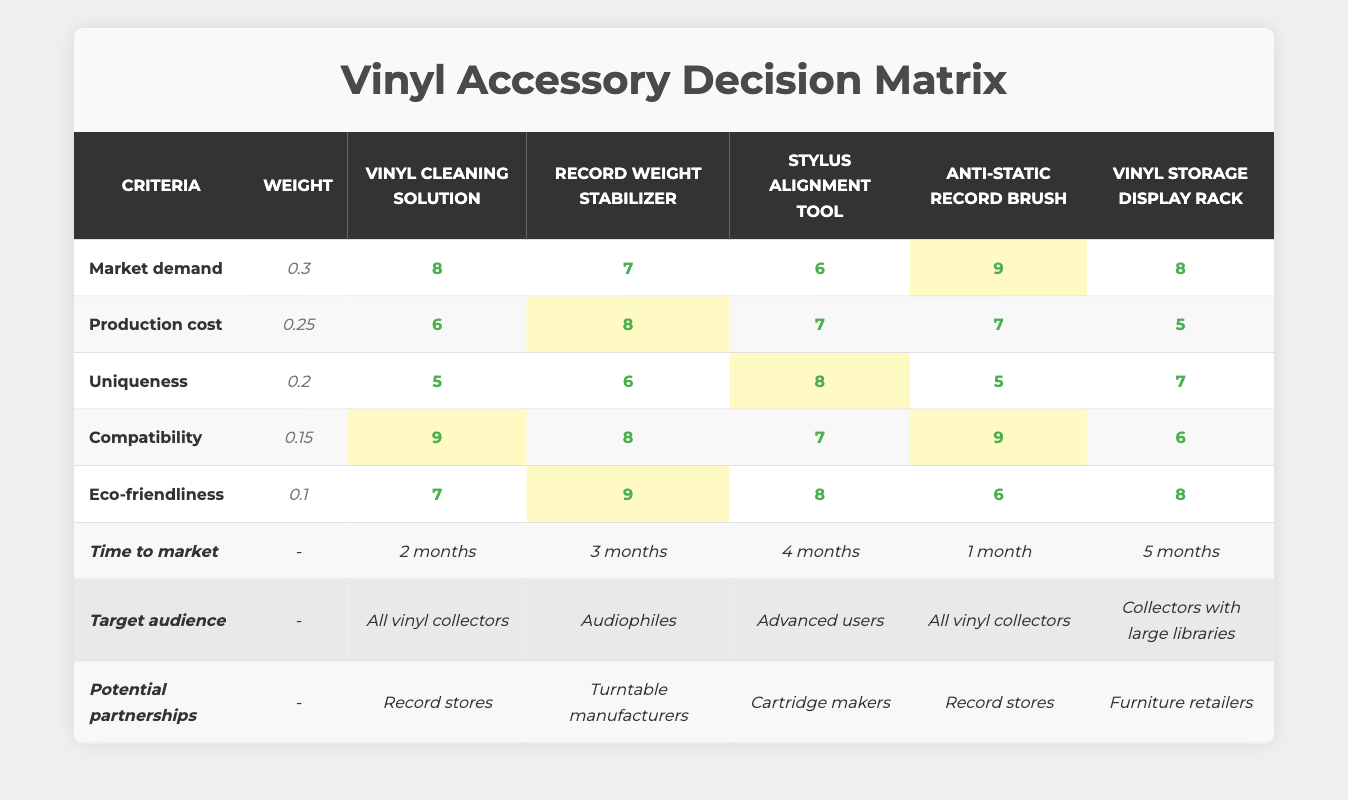What is the score for Eco-friendliness for the Record weight stabilizer? The score for Eco-friendliness is listed under the Record weight stabilizer column in the Eco-friendliness row. The value there is 9.
Answer: 9 Which accessory has the highest score for Market demand? To determine the highest score in the Market demand row, we can compare the individual scores: Vinyl cleaning solution (8), Record weight stabilizer (7), Stylus alignment tool (6), Anti-static record brush (9), and Vinyl storage display rack (8). The highest score is 9 for the Anti-static record brush.
Answer: 9 What is the total score for the Vinyl cleaning solution? The scores for the Vinyl cleaning solution are scored under each criterion: Market demand (8), Production cost (6), Uniqueness (5), Compatibility (9), and Eco-friendliness (7). Summing these values gives us 8 + 6 + 5 + 9 + 7 = 35.
Answer: 35 Which accessory has the fastest Time to market, and what is it? We can compare the times listed for each accessory: Vinyl cleaning solution (2 months), Record weight stabilizer (3 months), Stylus alignment tool (4 months), Anti-static record brush (1 month), and Vinyl storage display rack (5 months). The fastest is the Anti-static record brush with 1 month.
Answer: Anti-static record brush, 1 month Is the Stylus alignment tool compatible with all vinyl collectors? Looking at the Compatibility row, the score for the Stylus alignment tool is 7, which indicates it is not specifically aimed at all vinyl collectors. The target audience for the Stylus alignment tool is described as Advanced users. Therefore, the fact is false.
Answer: No What would be the average score for Compatibility among all accessories? The individual scores for Compatibility are: Vinyl cleaning solution (9), Record weight stabilizer (8), Stylus alignment tool (7), Anti-static record brush (9), and Vinyl storage display rack (6). We first sum the scores: 9 + 8 + 7 + 9 + 6 = 39. There are 5 accessories, so we calculate the average as 39/5 = 7.8.
Answer: 7.8 Which accessory targets Advanced users, and what partnerships can it pursue? The Stylus alignment tool is identified as targeting Advanced users. According to the Potential partnerships row, it can pursue partnerships with Cartridge makers for its distribution and marketing.
Answer: Stylus alignment tool, Cartridge makers Does the Record weight stabilizer have the lowest score in Production cost? The Production cost scores to compare are: Vinyl cleaning solution (6), Record weight stabilizer (8), Stylus alignment tool (7), Anti-static record brush (7), and Vinyl storage display rack (5). The lowest score is 5 for the Vinyl storage display rack, so the Record weight stabilizer does not have the lowest score.
Answer: No 